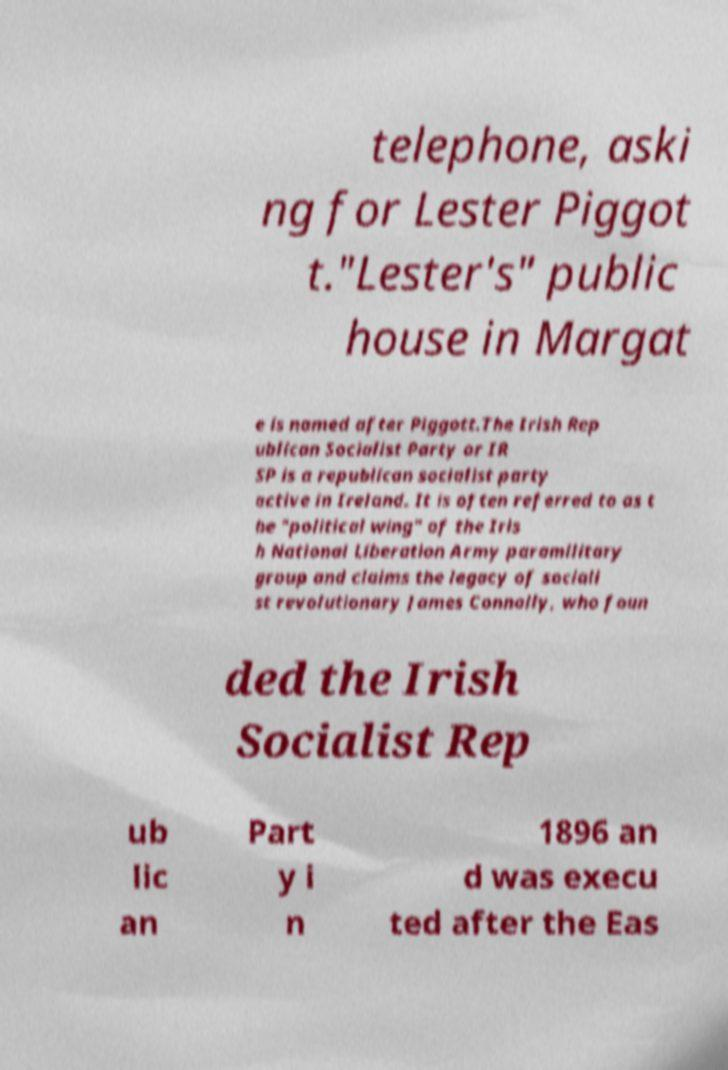Could you assist in decoding the text presented in this image and type it out clearly? telephone, aski ng for Lester Piggot t."Lester's" public house in Margat e is named after Piggott.The Irish Rep ublican Socialist Party or IR SP is a republican socialist party active in Ireland. It is often referred to as t he "political wing" of the Iris h National Liberation Army paramilitary group and claims the legacy of sociali st revolutionary James Connolly, who foun ded the Irish Socialist Rep ub lic an Part y i n 1896 an d was execu ted after the Eas 